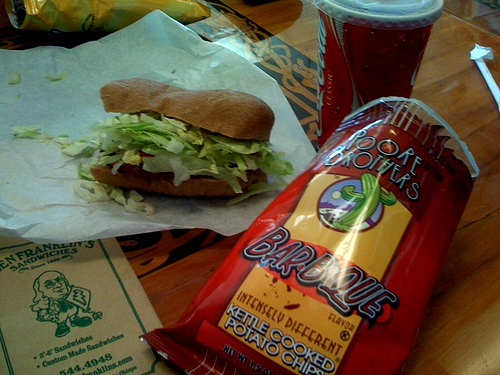Can you describe the drink that's in the cup? The cup contains a reddish beverage, which could likely be a soda, based on the color and the context of being paired with a sandwich and chips. 